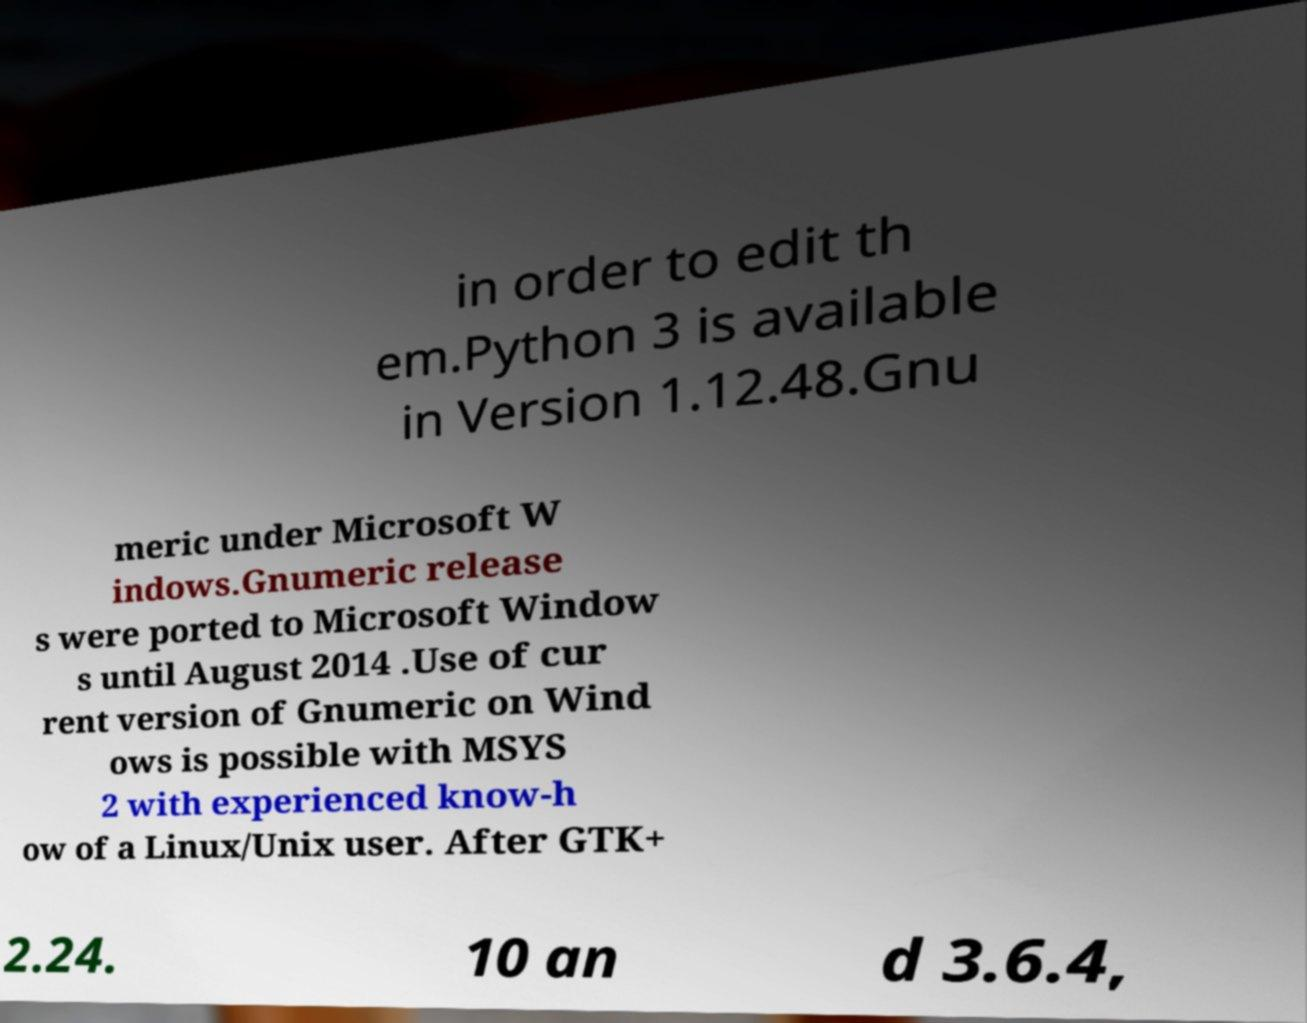Please identify and transcribe the text found in this image. in order to edit th em.Python 3 is available in Version 1.12.48.Gnu meric under Microsoft W indows.Gnumeric release s were ported to Microsoft Window s until August 2014 .Use of cur rent version of Gnumeric on Wind ows is possible with MSYS 2 with experienced know-h ow of a Linux/Unix user. After GTK+ 2.24. 10 an d 3.6.4, 